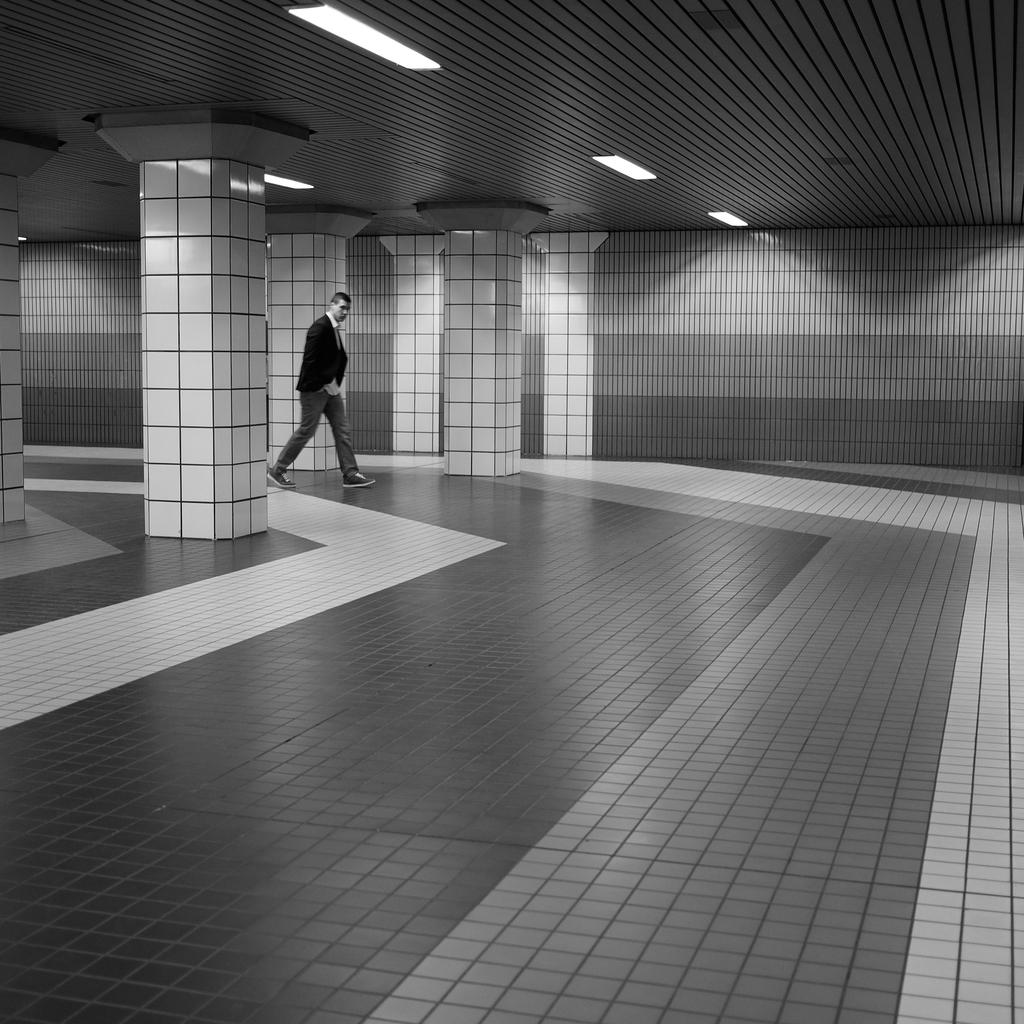What is the person in the image doing? The person in the image is walking. Where is the person walking? The image shows the interior of a building. What can be seen attached to the roof in the image? There are lights attached to the roof in the image. What type of boat can be seen in the image? There is no boat present in the image; it shows the interior of a building. 